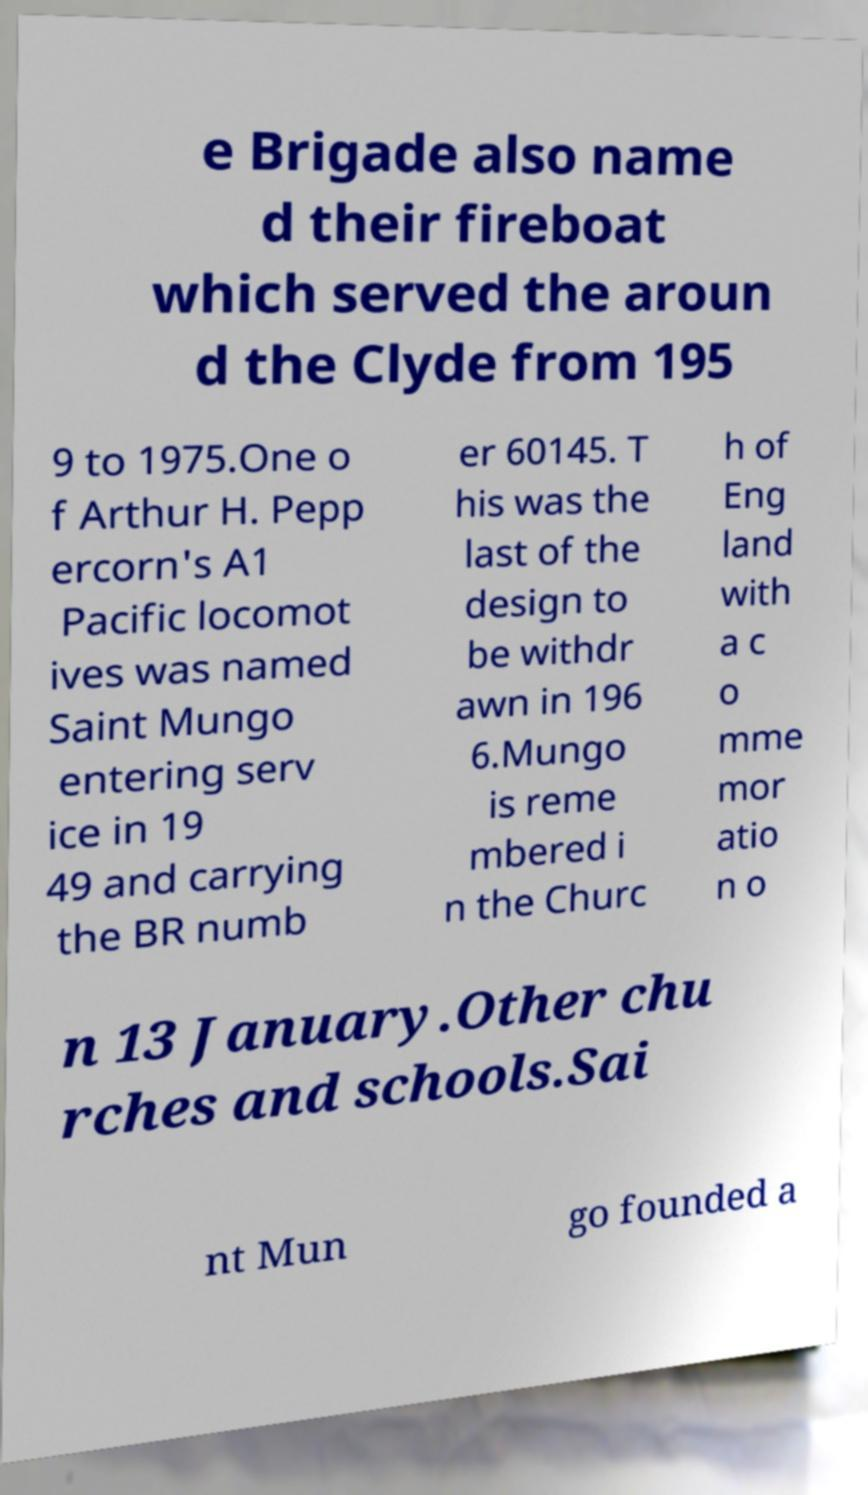I need the written content from this picture converted into text. Can you do that? e Brigade also name d their fireboat which served the aroun d the Clyde from 195 9 to 1975.One o f Arthur H. Pepp ercorn's A1 Pacific locomot ives was named Saint Mungo entering serv ice in 19 49 and carrying the BR numb er 60145. T his was the last of the design to be withdr awn in 196 6.Mungo is reme mbered i n the Churc h of Eng land with a c o mme mor atio n o n 13 January.Other chu rches and schools.Sai nt Mun go founded a 